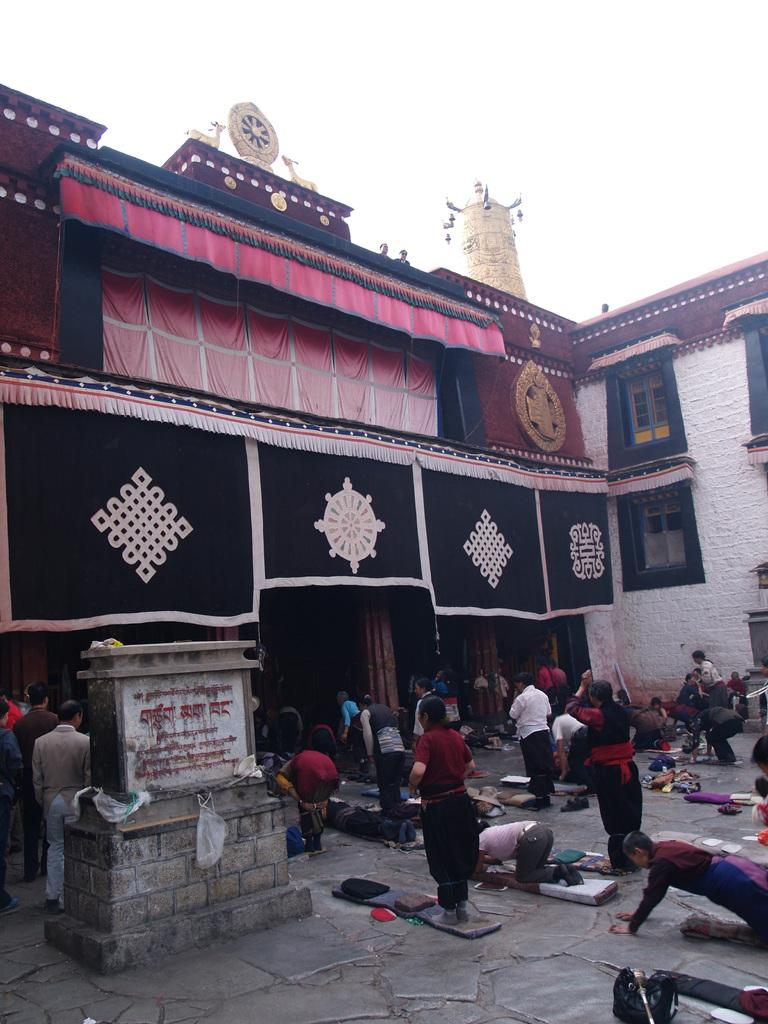How many people are in the image? There are many people in the image. What are the people doing in the image? The people are bowing or standing in front of a temple. What is visible above the temple in the image? The sky is visible above the temple. Can you see any ants crawling on the earth in the image? There is no reference to ants or the earth in the image, so it's not possible to determine if any ants are crawling on the earth. What type of horn is being played by the people in the image? There is no horn or any musical instrument visible in the image. 